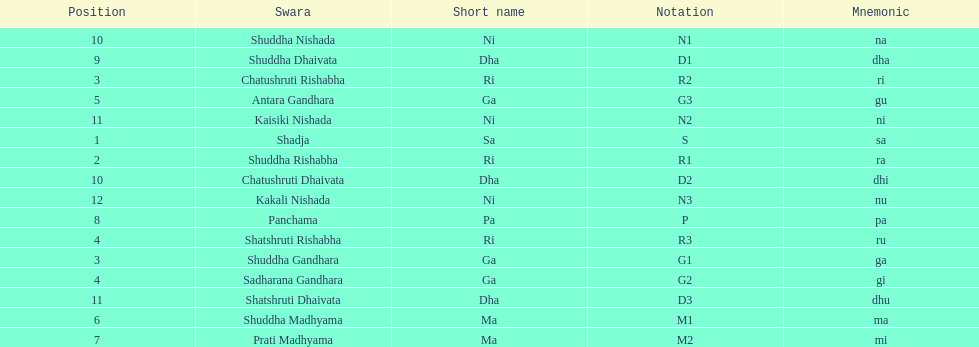What swara is above shatshruti dhaivata? Shuddha Nishada. 